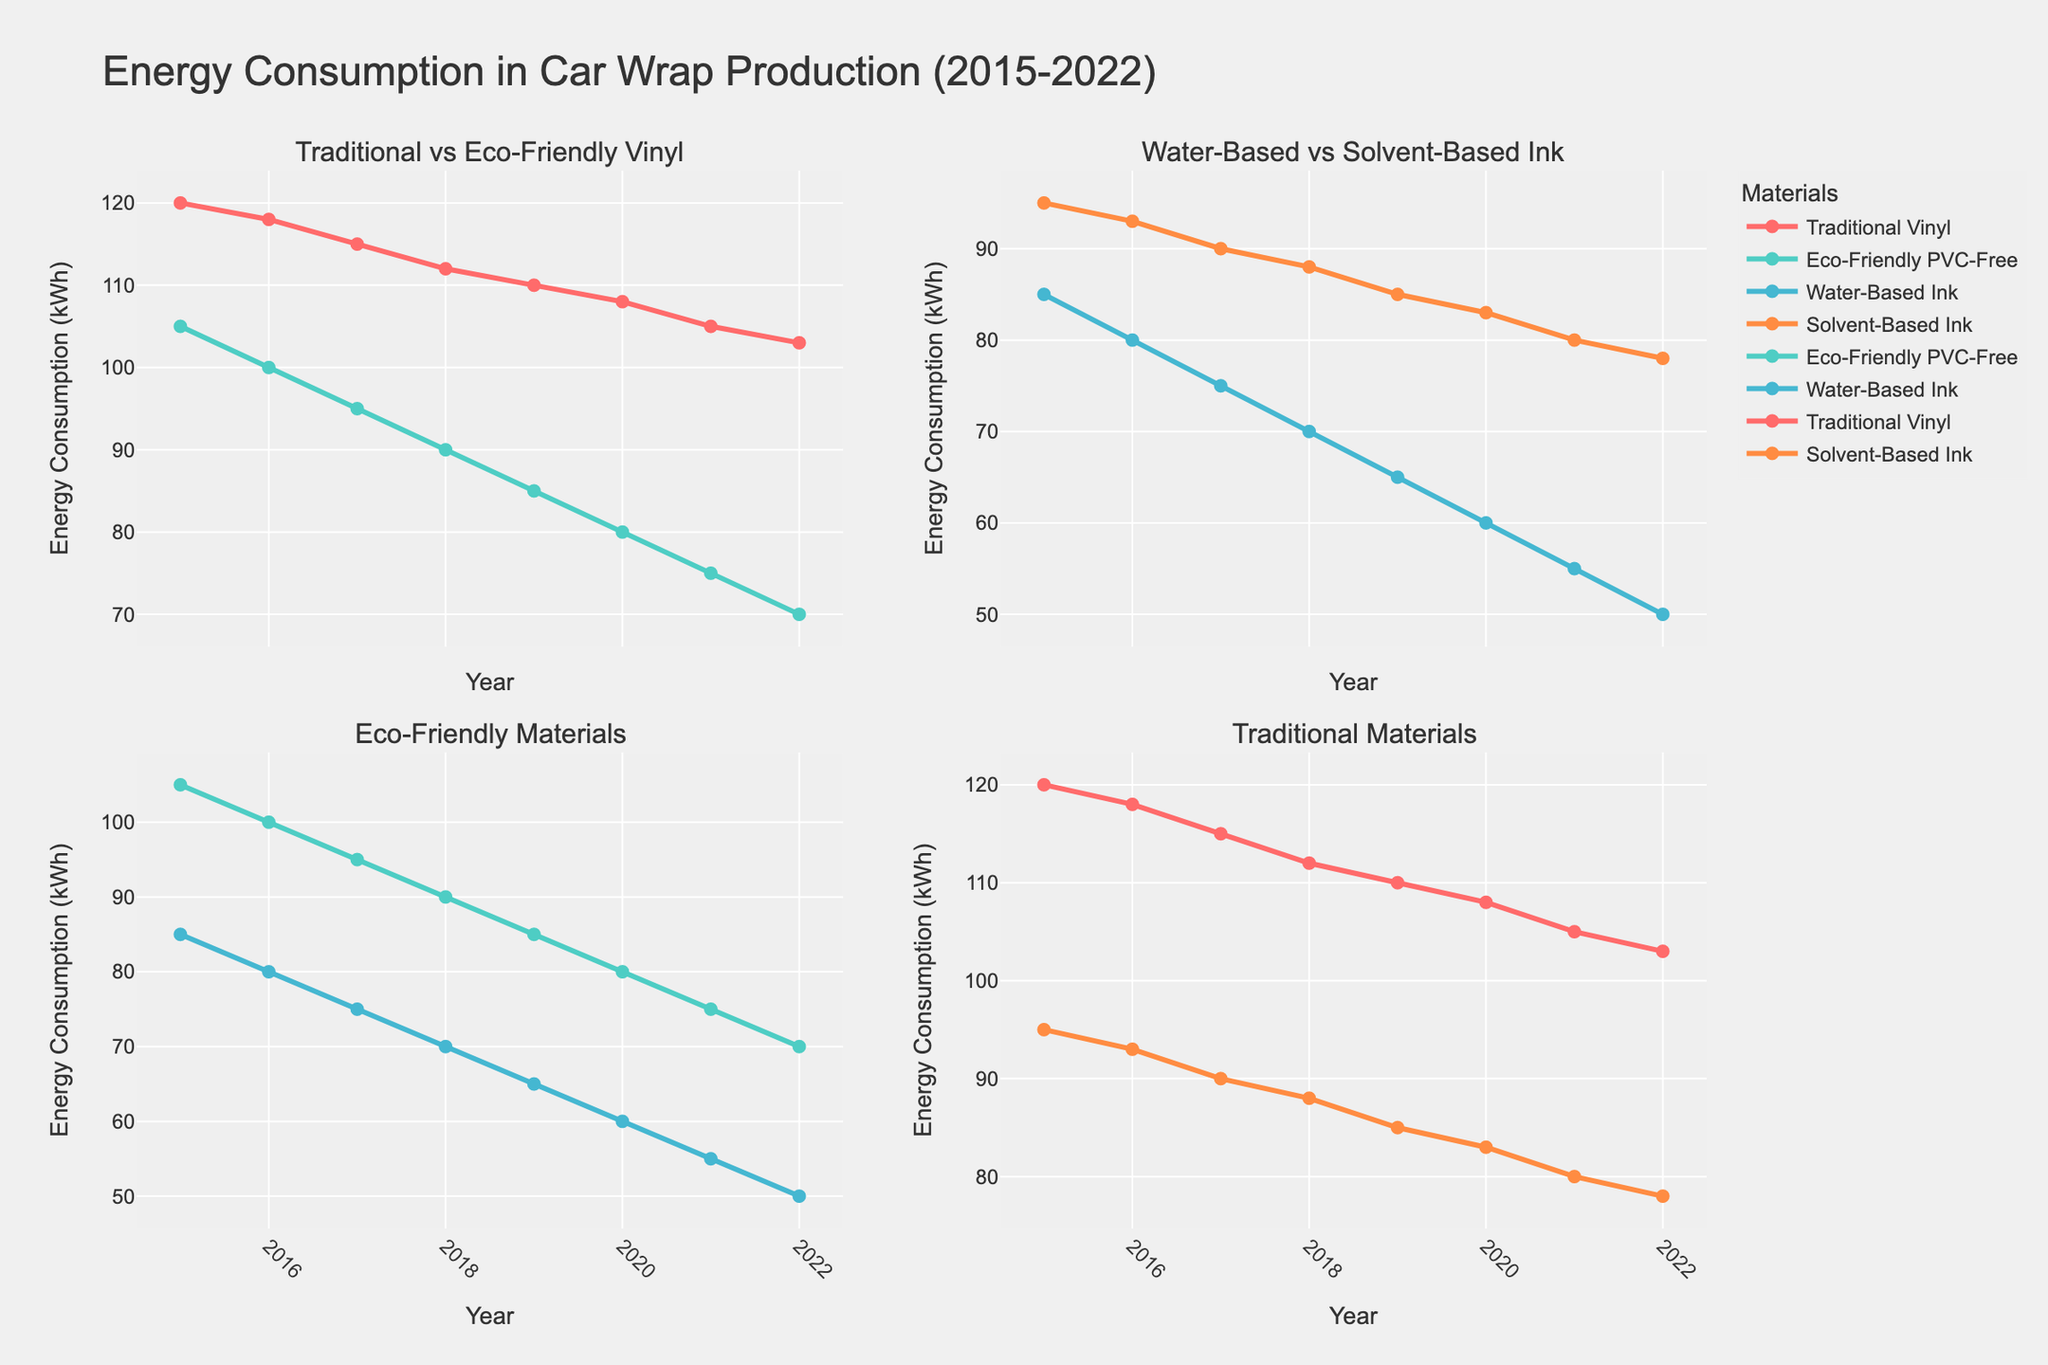How many years of data are shown in the figure? The x-axis of the plots shows the 'Year' values from 2015 to 2022, which covers 8 years in total.
Answer: 8 What is the title of the figure? The title of the figure is located at the top center. It reads "Energy Consumption in Car Wrap Production (2015-2022)".
Answer: Energy Consumption in Car Wrap Production (2015-2022) Which material showed the greatest reduction in energy consumption over the period 2015 to 2022? The plot comparing "Traditional Vinyl" and "Eco-Friendly PVC-Free" shows that both lines are decreasing, but the "Eco-Friendly PVC-Free" line drops more steeply from 105 kWh to 70 kWh, a 35 kWh reduction. This is the largest reduction compared to the others shown.
Answer: Eco-Friendly PVC-Free For which year was the energy consumption of water-based ink equal to the energy consumption of eco-friendly PVC-free vinyl? By observing the second-row, first-column plot, both lines for Water-Based Ink and Eco-Friendly PVC-Free intersect at the value of 70 kWh in the year 2022.
Answer: 2022 What is the average energy consumption of solvent-based ink over the period shown? The values for solvent-based ink from 2015 to 2022 are 95, 93, 90, 88, 85, 83, 80, and 78 kWh. Summing them gives 692 kWh, and the average is calculated as 692/8.
Answer: 86.5 Which material's energy consumption was higher in 2018, water-based ink or traditional vinyl? For 2018, the energy consumption values are 70 kWh for Water-Based Ink and 112 kWh for Traditional Vinyl. Comparing these, Traditional Vinyl has higher usage.
Answer: Traditional Vinyl By how many kWh did the energy consumption of traditional vinyl decrease from 2015 to 2022? In 2015, the energy consumption of Traditional Vinyl was 120 kWh, and it decreased to 103 kWh in 2022. The reduction can be calculated as 120 - 103.
Answer: 17 Which subplot compares eco-friendly technologies directly against each other? The subplot in the second row, first column compares "Eco-Friendly PVC-Free" and "Water-Based Ink", which are both eco-friendly technologies.
Answer: The subplot in the second row, first column What is the consistent trend observed across all subplots for all materials from 2015 to 2022? All the lines in every subplot show a decreasing trend, indicating a consistent reduction in energy consumption across all materials from 2015 to 2022.
Answer: Decreasing trend In which subplot do you find the lowest energy consumption value, and what is that value? The second row, first column subplot, comparing "Eco-Friendly PVC-Free" and "Water-Based Ink", shows the lowest value of 50 kWh for "Water-Based Ink" in 2022.
Answer: Second row, first column, 50 kWh 